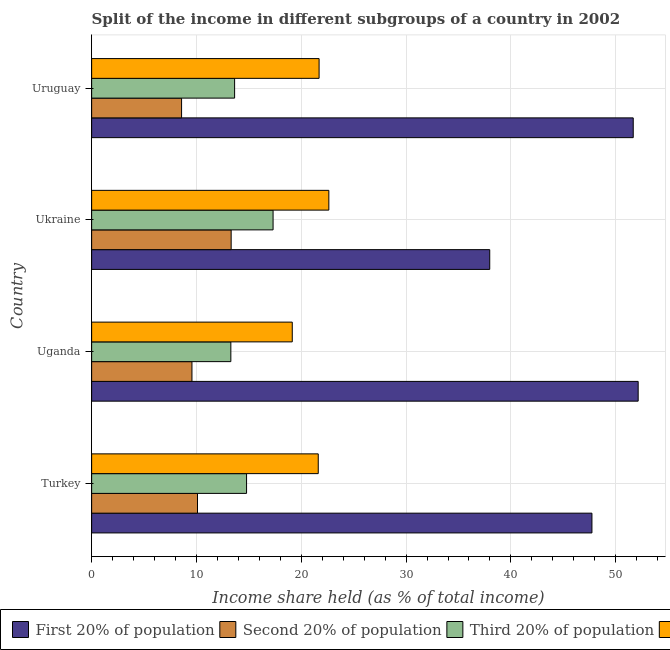Are the number of bars on each tick of the Y-axis equal?
Make the answer very short. Yes. How many bars are there on the 4th tick from the bottom?
Make the answer very short. 4. What is the label of the 3rd group of bars from the top?
Give a very brief answer. Uganda. What is the share of the income held by second 20% of the population in Uruguay?
Give a very brief answer. 8.58. Across all countries, what is the maximum share of the income held by third 20% of the population?
Provide a short and direct response. 17.31. Across all countries, what is the minimum share of the income held by second 20% of the population?
Provide a succinct answer. 8.58. In which country was the share of the income held by first 20% of the population maximum?
Make the answer very short. Uganda. In which country was the share of the income held by second 20% of the population minimum?
Offer a terse response. Uruguay. What is the total share of the income held by third 20% of the population in the graph?
Keep it short and to the point. 59.01. What is the difference between the share of the income held by first 20% of the population in Turkey and that in Uruguay?
Make the answer very short. -3.94. What is the difference between the share of the income held by first 20% of the population in Turkey and the share of the income held by second 20% of the population in Uganda?
Give a very brief answer. 38.16. What is the average share of the income held by fourth 20% of the population per country?
Offer a very short reply. 21.27. What is the difference between the share of the income held by fourth 20% of the population and share of the income held by third 20% of the population in Turkey?
Offer a very short reply. 6.84. In how many countries, is the share of the income held by second 20% of the population greater than 22 %?
Provide a short and direct response. 0. What is the ratio of the share of the income held by fourth 20% of the population in Ukraine to that in Uruguay?
Your answer should be compact. 1.04. Is the difference between the share of the income held by second 20% of the population in Uganda and Ukraine greater than the difference between the share of the income held by first 20% of the population in Uganda and Ukraine?
Give a very brief answer. No. What is the difference between the highest and the second highest share of the income held by third 20% of the population?
Ensure brevity in your answer.  2.53. What is the difference between the highest and the lowest share of the income held by second 20% of the population?
Provide a short and direct response. 4.73. Is the sum of the share of the income held by fourth 20% of the population in Turkey and Uganda greater than the maximum share of the income held by second 20% of the population across all countries?
Keep it short and to the point. Yes. Is it the case that in every country, the sum of the share of the income held by first 20% of the population and share of the income held by third 20% of the population is greater than the sum of share of the income held by fourth 20% of the population and share of the income held by second 20% of the population?
Make the answer very short. No. What does the 1st bar from the top in Turkey represents?
Your answer should be compact. Fourth 20% of population. What does the 4th bar from the bottom in Turkey represents?
Your answer should be very brief. Fourth 20% of population. Does the graph contain any zero values?
Keep it short and to the point. No. Does the graph contain grids?
Your answer should be very brief. Yes. How are the legend labels stacked?
Offer a terse response. Horizontal. What is the title of the graph?
Make the answer very short. Split of the income in different subgroups of a country in 2002. Does "Coal" appear as one of the legend labels in the graph?
Ensure brevity in your answer.  No. What is the label or title of the X-axis?
Keep it short and to the point. Income share held (as % of total income). What is the Income share held (as % of total income) in First 20% of population in Turkey?
Your response must be concise. 47.73. What is the Income share held (as % of total income) in Second 20% of population in Turkey?
Your answer should be compact. 10.1. What is the Income share held (as % of total income) of Third 20% of population in Turkey?
Keep it short and to the point. 14.78. What is the Income share held (as % of total income) in Fourth 20% of population in Turkey?
Your answer should be compact. 21.62. What is the Income share held (as % of total income) in First 20% of population in Uganda?
Make the answer very short. 52.14. What is the Income share held (as % of total income) in Second 20% of population in Uganda?
Offer a terse response. 9.57. What is the Income share held (as % of total income) in Third 20% of population in Uganda?
Provide a succinct answer. 13.28. What is the Income share held (as % of total income) of Fourth 20% of population in Uganda?
Ensure brevity in your answer.  19.14. What is the Income share held (as % of total income) of First 20% of population in Ukraine?
Your answer should be compact. 37.98. What is the Income share held (as % of total income) of Second 20% of population in Ukraine?
Give a very brief answer. 13.31. What is the Income share held (as % of total income) in Third 20% of population in Ukraine?
Give a very brief answer. 17.31. What is the Income share held (as % of total income) in Fourth 20% of population in Ukraine?
Your response must be concise. 22.63. What is the Income share held (as % of total income) of First 20% of population in Uruguay?
Give a very brief answer. 51.67. What is the Income share held (as % of total income) in Second 20% of population in Uruguay?
Provide a succinct answer. 8.58. What is the Income share held (as % of total income) of Third 20% of population in Uruguay?
Give a very brief answer. 13.64. What is the Income share held (as % of total income) in Fourth 20% of population in Uruguay?
Keep it short and to the point. 21.7. Across all countries, what is the maximum Income share held (as % of total income) of First 20% of population?
Make the answer very short. 52.14. Across all countries, what is the maximum Income share held (as % of total income) of Second 20% of population?
Your response must be concise. 13.31. Across all countries, what is the maximum Income share held (as % of total income) in Third 20% of population?
Offer a terse response. 17.31. Across all countries, what is the maximum Income share held (as % of total income) in Fourth 20% of population?
Make the answer very short. 22.63. Across all countries, what is the minimum Income share held (as % of total income) of First 20% of population?
Give a very brief answer. 37.98. Across all countries, what is the minimum Income share held (as % of total income) of Second 20% of population?
Make the answer very short. 8.58. Across all countries, what is the minimum Income share held (as % of total income) of Third 20% of population?
Your response must be concise. 13.28. Across all countries, what is the minimum Income share held (as % of total income) of Fourth 20% of population?
Provide a succinct answer. 19.14. What is the total Income share held (as % of total income) in First 20% of population in the graph?
Make the answer very short. 189.52. What is the total Income share held (as % of total income) of Second 20% of population in the graph?
Provide a succinct answer. 41.56. What is the total Income share held (as % of total income) of Third 20% of population in the graph?
Offer a terse response. 59.01. What is the total Income share held (as % of total income) of Fourth 20% of population in the graph?
Offer a very short reply. 85.09. What is the difference between the Income share held (as % of total income) in First 20% of population in Turkey and that in Uganda?
Your response must be concise. -4.41. What is the difference between the Income share held (as % of total income) in Second 20% of population in Turkey and that in Uganda?
Your answer should be very brief. 0.53. What is the difference between the Income share held (as % of total income) of Third 20% of population in Turkey and that in Uganda?
Ensure brevity in your answer.  1.5. What is the difference between the Income share held (as % of total income) in Fourth 20% of population in Turkey and that in Uganda?
Offer a terse response. 2.48. What is the difference between the Income share held (as % of total income) of First 20% of population in Turkey and that in Ukraine?
Your answer should be compact. 9.75. What is the difference between the Income share held (as % of total income) of Second 20% of population in Turkey and that in Ukraine?
Provide a short and direct response. -3.21. What is the difference between the Income share held (as % of total income) of Third 20% of population in Turkey and that in Ukraine?
Provide a succinct answer. -2.53. What is the difference between the Income share held (as % of total income) in Fourth 20% of population in Turkey and that in Ukraine?
Give a very brief answer. -1.01. What is the difference between the Income share held (as % of total income) in First 20% of population in Turkey and that in Uruguay?
Make the answer very short. -3.94. What is the difference between the Income share held (as % of total income) in Second 20% of population in Turkey and that in Uruguay?
Offer a very short reply. 1.52. What is the difference between the Income share held (as % of total income) in Third 20% of population in Turkey and that in Uruguay?
Give a very brief answer. 1.14. What is the difference between the Income share held (as % of total income) in Fourth 20% of population in Turkey and that in Uruguay?
Your response must be concise. -0.08. What is the difference between the Income share held (as % of total income) of First 20% of population in Uganda and that in Ukraine?
Your answer should be very brief. 14.16. What is the difference between the Income share held (as % of total income) of Second 20% of population in Uganda and that in Ukraine?
Your response must be concise. -3.74. What is the difference between the Income share held (as % of total income) of Third 20% of population in Uganda and that in Ukraine?
Offer a very short reply. -4.03. What is the difference between the Income share held (as % of total income) of Fourth 20% of population in Uganda and that in Ukraine?
Keep it short and to the point. -3.49. What is the difference between the Income share held (as % of total income) in First 20% of population in Uganda and that in Uruguay?
Offer a terse response. 0.47. What is the difference between the Income share held (as % of total income) of Second 20% of population in Uganda and that in Uruguay?
Offer a terse response. 0.99. What is the difference between the Income share held (as % of total income) in Third 20% of population in Uganda and that in Uruguay?
Keep it short and to the point. -0.36. What is the difference between the Income share held (as % of total income) of Fourth 20% of population in Uganda and that in Uruguay?
Your answer should be compact. -2.56. What is the difference between the Income share held (as % of total income) of First 20% of population in Ukraine and that in Uruguay?
Provide a succinct answer. -13.69. What is the difference between the Income share held (as % of total income) of Second 20% of population in Ukraine and that in Uruguay?
Your answer should be compact. 4.73. What is the difference between the Income share held (as % of total income) in Third 20% of population in Ukraine and that in Uruguay?
Provide a succinct answer. 3.67. What is the difference between the Income share held (as % of total income) of Fourth 20% of population in Ukraine and that in Uruguay?
Your answer should be compact. 0.93. What is the difference between the Income share held (as % of total income) in First 20% of population in Turkey and the Income share held (as % of total income) in Second 20% of population in Uganda?
Your answer should be very brief. 38.16. What is the difference between the Income share held (as % of total income) in First 20% of population in Turkey and the Income share held (as % of total income) in Third 20% of population in Uganda?
Provide a short and direct response. 34.45. What is the difference between the Income share held (as % of total income) of First 20% of population in Turkey and the Income share held (as % of total income) of Fourth 20% of population in Uganda?
Make the answer very short. 28.59. What is the difference between the Income share held (as % of total income) of Second 20% of population in Turkey and the Income share held (as % of total income) of Third 20% of population in Uganda?
Provide a short and direct response. -3.18. What is the difference between the Income share held (as % of total income) in Second 20% of population in Turkey and the Income share held (as % of total income) in Fourth 20% of population in Uganda?
Ensure brevity in your answer.  -9.04. What is the difference between the Income share held (as % of total income) in Third 20% of population in Turkey and the Income share held (as % of total income) in Fourth 20% of population in Uganda?
Offer a terse response. -4.36. What is the difference between the Income share held (as % of total income) in First 20% of population in Turkey and the Income share held (as % of total income) in Second 20% of population in Ukraine?
Make the answer very short. 34.42. What is the difference between the Income share held (as % of total income) in First 20% of population in Turkey and the Income share held (as % of total income) in Third 20% of population in Ukraine?
Your response must be concise. 30.42. What is the difference between the Income share held (as % of total income) of First 20% of population in Turkey and the Income share held (as % of total income) of Fourth 20% of population in Ukraine?
Keep it short and to the point. 25.1. What is the difference between the Income share held (as % of total income) in Second 20% of population in Turkey and the Income share held (as % of total income) in Third 20% of population in Ukraine?
Give a very brief answer. -7.21. What is the difference between the Income share held (as % of total income) in Second 20% of population in Turkey and the Income share held (as % of total income) in Fourth 20% of population in Ukraine?
Your answer should be compact. -12.53. What is the difference between the Income share held (as % of total income) of Third 20% of population in Turkey and the Income share held (as % of total income) of Fourth 20% of population in Ukraine?
Give a very brief answer. -7.85. What is the difference between the Income share held (as % of total income) in First 20% of population in Turkey and the Income share held (as % of total income) in Second 20% of population in Uruguay?
Your answer should be compact. 39.15. What is the difference between the Income share held (as % of total income) of First 20% of population in Turkey and the Income share held (as % of total income) of Third 20% of population in Uruguay?
Give a very brief answer. 34.09. What is the difference between the Income share held (as % of total income) in First 20% of population in Turkey and the Income share held (as % of total income) in Fourth 20% of population in Uruguay?
Offer a very short reply. 26.03. What is the difference between the Income share held (as % of total income) in Second 20% of population in Turkey and the Income share held (as % of total income) in Third 20% of population in Uruguay?
Your answer should be very brief. -3.54. What is the difference between the Income share held (as % of total income) of Third 20% of population in Turkey and the Income share held (as % of total income) of Fourth 20% of population in Uruguay?
Offer a terse response. -6.92. What is the difference between the Income share held (as % of total income) of First 20% of population in Uganda and the Income share held (as % of total income) of Second 20% of population in Ukraine?
Your answer should be compact. 38.83. What is the difference between the Income share held (as % of total income) in First 20% of population in Uganda and the Income share held (as % of total income) in Third 20% of population in Ukraine?
Provide a short and direct response. 34.83. What is the difference between the Income share held (as % of total income) in First 20% of population in Uganda and the Income share held (as % of total income) in Fourth 20% of population in Ukraine?
Offer a terse response. 29.51. What is the difference between the Income share held (as % of total income) in Second 20% of population in Uganda and the Income share held (as % of total income) in Third 20% of population in Ukraine?
Your answer should be compact. -7.74. What is the difference between the Income share held (as % of total income) in Second 20% of population in Uganda and the Income share held (as % of total income) in Fourth 20% of population in Ukraine?
Offer a very short reply. -13.06. What is the difference between the Income share held (as % of total income) of Third 20% of population in Uganda and the Income share held (as % of total income) of Fourth 20% of population in Ukraine?
Offer a terse response. -9.35. What is the difference between the Income share held (as % of total income) in First 20% of population in Uganda and the Income share held (as % of total income) in Second 20% of population in Uruguay?
Give a very brief answer. 43.56. What is the difference between the Income share held (as % of total income) in First 20% of population in Uganda and the Income share held (as % of total income) in Third 20% of population in Uruguay?
Your response must be concise. 38.5. What is the difference between the Income share held (as % of total income) in First 20% of population in Uganda and the Income share held (as % of total income) in Fourth 20% of population in Uruguay?
Your response must be concise. 30.44. What is the difference between the Income share held (as % of total income) in Second 20% of population in Uganda and the Income share held (as % of total income) in Third 20% of population in Uruguay?
Your response must be concise. -4.07. What is the difference between the Income share held (as % of total income) of Second 20% of population in Uganda and the Income share held (as % of total income) of Fourth 20% of population in Uruguay?
Your answer should be very brief. -12.13. What is the difference between the Income share held (as % of total income) of Third 20% of population in Uganda and the Income share held (as % of total income) of Fourth 20% of population in Uruguay?
Your answer should be compact. -8.42. What is the difference between the Income share held (as % of total income) in First 20% of population in Ukraine and the Income share held (as % of total income) in Second 20% of population in Uruguay?
Ensure brevity in your answer.  29.4. What is the difference between the Income share held (as % of total income) of First 20% of population in Ukraine and the Income share held (as % of total income) of Third 20% of population in Uruguay?
Offer a very short reply. 24.34. What is the difference between the Income share held (as % of total income) of First 20% of population in Ukraine and the Income share held (as % of total income) of Fourth 20% of population in Uruguay?
Keep it short and to the point. 16.28. What is the difference between the Income share held (as % of total income) in Second 20% of population in Ukraine and the Income share held (as % of total income) in Third 20% of population in Uruguay?
Keep it short and to the point. -0.33. What is the difference between the Income share held (as % of total income) in Second 20% of population in Ukraine and the Income share held (as % of total income) in Fourth 20% of population in Uruguay?
Give a very brief answer. -8.39. What is the difference between the Income share held (as % of total income) in Third 20% of population in Ukraine and the Income share held (as % of total income) in Fourth 20% of population in Uruguay?
Your answer should be very brief. -4.39. What is the average Income share held (as % of total income) of First 20% of population per country?
Ensure brevity in your answer.  47.38. What is the average Income share held (as % of total income) in Second 20% of population per country?
Provide a short and direct response. 10.39. What is the average Income share held (as % of total income) of Third 20% of population per country?
Your answer should be compact. 14.75. What is the average Income share held (as % of total income) in Fourth 20% of population per country?
Offer a very short reply. 21.27. What is the difference between the Income share held (as % of total income) in First 20% of population and Income share held (as % of total income) in Second 20% of population in Turkey?
Provide a succinct answer. 37.63. What is the difference between the Income share held (as % of total income) of First 20% of population and Income share held (as % of total income) of Third 20% of population in Turkey?
Offer a terse response. 32.95. What is the difference between the Income share held (as % of total income) of First 20% of population and Income share held (as % of total income) of Fourth 20% of population in Turkey?
Give a very brief answer. 26.11. What is the difference between the Income share held (as % of total income) in Second 20% of population and Income share held (as % of total income) in Third 20% of population in Turkey?
Keep it short and to the point. -4.68. What is the difference between the Income share held (as % of total income) of Second 20% of population and Income share held (as % of total income) of Fourth 20% of population in Turkey?
Provide a short and direct response. -11.52. What is the difference between the Income share held (as % of total income) of Third 20% of population and Income share held (as % of total income) of Fourth 20% of population in Turkey?
Provide a short and direct response. -6.84. What is the difference between the Income share held (as % of total income) in First 20% of population and Income share held (as % of total income) in Second 20% of population in Uganda?
Your answer should be very brief. 42.57. What is the difference between the Income share held (as % of total income) of First 20% of population and Income share held (as % of total income) of Third 20% of population in Uganda?
Your answer should be compact. 38.86. What is the difference between the Income share held (as % of total income) in Second 20% of population and Income share held (as % of total income) in Third 20% of population in Uganda?
Your answer should be very brief. -3.71. What is the difference between the Income share held (as % of total income) of Second 20% of population and Income share held (as % of total income) of Fourth 20% of population in Uganda?
Offer a very short reply. -9.57. What is the difference between the Income share held (as % of total income) of Third 20% of population and Income share held (as % of total income) of Fourth 20% of population in Uganda?
Give a very brief answer. -5.86. What is the difference between the Income share held (as % of total income) in First 20% of population and Income share held (as % of total income) in Second 20% of population in Ukraine?
Offer a very short reply. 24.67. What is the difference between the Income share held (as % of total income) of First 20% of population and Income share held (as % of total income) of Third 20% of population in Ukraine?
Your answer should be compact. 20.67. What is the difference between the Income share held (as % of total income) of First 20% of population and Income share held (as % of total income) of Fourth 20% of population in Ukraine?
Provide a short and direct response. 15.35. What is the difference between the Income share held (as % of total income) of Second 20% of population and Income share held (as % of total income) of Third 20% of population in Ukraine?
Give a very brief answer. -4. What is the difference between the Income share held (as % of total income) of Second 20% of population and Income share held (as % of total income) of Fourth 20% of population in Ukraine?
Your answer should be compact. -9.32. What is the difference between the Income share held (as % of total income) of Third 20% of population and Income share held (as % of total income) of Fourth 20% of population in Ukraine?
Make the answer very short. -5.32. What is the difference between the Income share held (as % of total income) in First 20% of population and Income share held (as % of total income) in Second 20% of population in Uruguay?
Ensure brevity in your answer.  43.09. What is the difference between the Income share held (as % of total income) of First 20% of population and Income share held (as % of total income) of Third 20% of population in Uruguay?
Your answer should be very brief. 38.03. What is the difference between the Income share held (as % of total income) of First 20% of population and Income share held (as % of total income) of Fourth 20% of population in Uruguay?
Offer a terse response. 29.97. What is the difference between the Income share held (as % of total income) in Second 20% of population and Income share held (as % of total income) in Third 20% of population in Uruguay?
Give a very brief answer. -5.06. What is the difference between the Income share held (as % of total income) in Second 20% of population and Income share held (as % of total income) in Fourth 20% of population in Uruguay?
Keep it short and to the point. -13.12. What is the difference between the Income share held (as % of total income) in Third 20% of population and Income share held (as % of total income) in Fourth 20% of population in Uruguay?
Give a very brief answer. -8.06. What is the ratio of the Income share held (as % of total income) in First 20% of population in Turkey to that in Uganda?
Your answer should be compact. 0.92. What is the ratio of the Income share held (as % of total income) of Second 20% of population in Turkey to that in Uganda?
Your response must be concise. 1.06. What is the ratio of the Income share held (as % of total income) of Third 20% of population in Turkey to that in Uganda?
Ensure brevity in your answer.  1.11. What is the ratio of the Income share held (as % of total income) in Fourth 20% of population in Turkey to that in Uganda?
Your answer should be compact. 1.13. What is the ratio of the Income share held (as % of total income) of First 20% of population in Turkey to that in Ukraine?
Offer a terse response. 1.26. What is the ratio of the Income share held (as % of total income) of Second 20% of population in Turkey to that in Ukraine?
Give a very brief answer. 0.76. What is the ratio of the Income share held (as % of total income) of Third 20% of population in Turkey to that in Ukraine?
Make the answer very short. 0.85. What is the ratio of the Income share held (as % of total income) in Fourth 20% of population in Turkey to that in Ukraine?
Your answer should be very brief. 0.96. What is the ratio of the Income share held (as % of total income) of First 20% of population in Turkey to that in Uruguay?
Your answer should be very brief. 0.92. What is the ratio of the Income share held (as % of total income) in Second 20% of population in Turkey to that in Uruguay?
Provide a short and direct response. 1.18. What is the ratio of the Income share held (as % of total income) in Third 20% of population in Turkey to that in Uruguay?
Ensure brevity in your answer.  1.08. What is the ratio of the Income share held (as % of total income) of Fourth 20% of population in Turkey to that in Uruguay?
Your answer should be compact. 1. What is the ratio of the Income share held (as % of total income) in First 20% of population in Uganda to that in Ukraine?
Ensure brevity in your answer.  1.37. What is the ratio of the Income share held (as % of total income) of Second 20% of population in Uganda to that in Ukraine?
Give a very brief answer. 0.72. What is the ratio of the Income share held (as % of total income) in Third 20% of population in Uganda to that in Ukraine?
Your answer should be very brief. 0.77. What is the ratio of the Income share held (as % of total income) in Fourth 20% of population in Uganda to that in Ukraine?
Keep it short and to the point. 0.85. What is the ratio of the Income share held (as % of total income) in First 20% of population in Uganda to that in Uruguay?
Provide a short and direct response. 1.01. What is the ratio of the Income share held (as % of total income) of Second 20% of population in Uganda to that in Uruguay?
Ensure brevity in your answer.  1.12. What is the ratio of the Income share held (as % of total income) in Third 20% of population in Uganda to that in Uruguay?
Ensure brevity in your answer.  0.97. What is the ratio of the Income share held (as % of total income) of Fourth 20% of population in Uganda to that in Uruguay?
Make the answer very short. 0.88. What is the ratio of the Income share held (as % of total income) of First 20% of population in Ukraine to that in Uruguay?
Give a very brief answer. 0.73. What is the ratio of the Income share held (as % of total income) of Second 20% of population in Ukraine to that in Uruguay?
Make the answer very short. 1.55. What is the ratio of the Income share held (as % of total income) of Third 20% of population in Ukraine to that in Uruguay?
Provide a short and direct response. 1.27. What is the ratio of the Income share held (as % of total income) in Fourth 20% of population in Ukraine to that in Uruguay?
Provide a succinct answer. 1.04. What is the difference between the highest and the second highest Income share held (as % of total income) in First 20% of population?
Your response must be concise. 0.47. What is the difference between the highest and the second highest Income share held (as % of total income) in Second 20% of population?
Your answer should be very brief. 3.21. What is the difference between the highest and the second highest Income share held (as % of total income) of Third 20% of population?
Your answer should be compact. 2.53. What is the difference between the highest and the second highest Income share held (as % of total income) of Fourth 20% of population?
Provide a short and direct response. 0.93. What is the difference between the highest and the lowest Income share held (as % of total income) in First 20% of population?
Keep it short and to the point. 14.16. What is the difference between the highest and the lowest Income share held (as % of total income) in Second 20% of population?
Provide a succinct answer. 4.73. What is the difference between the highest and the lowest Income share held (as % of total income) in Third 20% of population?
Ensure brevity in your answer.  4.03. What is the difference between the highest and the lowest Income share held (as % of total income) of Fourth 20% of population?
Provide a succinct answer. 3.49. 